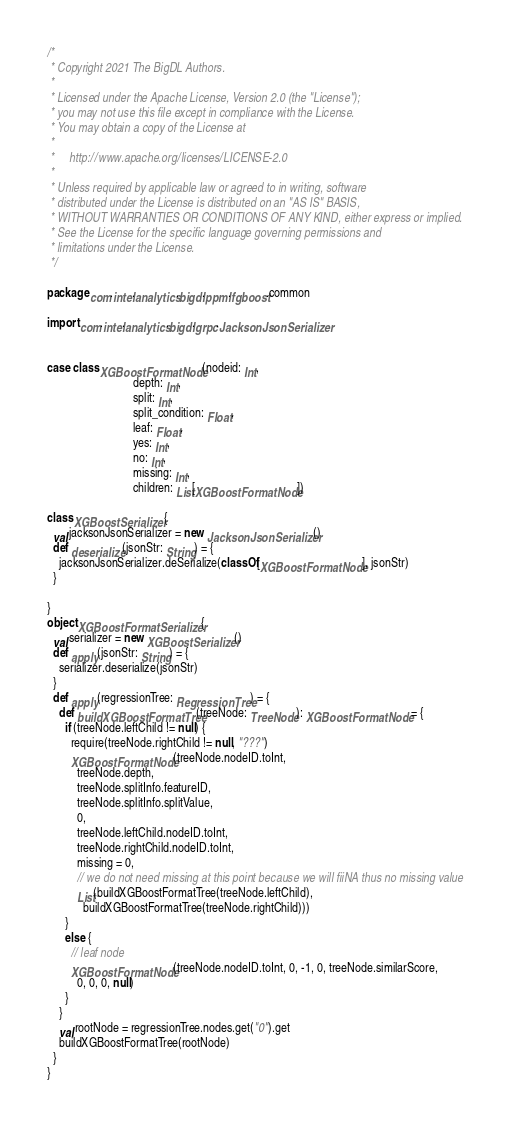<code> <loc_0><loc_0><loc_500><loc_500><_Scala_>/*
 * Copyright 2021 The BigDL Authors.
 *
 * Licensed under the Apache License, Version 2.0 (the "License");
 * you may not use this file except in compliance with the License.
 * You may obtain a copy of the License at
 *
 *     http://www.apache.org/licenses/LICENSE-2.0
 *
 * Unless required by applicable law or agreed to in writing, software
 * distributed under the License is distributed on an "AS IS" BASIS,
 * WITHOUT WARRANTIES OR CONDITIONS OF ANY KIND, either express or implied.
 * See the License for the specific language governing permissions and
 * limitations under the License.
 */

package com.intel.analytics.bigdl.ppml.fgboost.common

import com.intel.analytics.bigdl.grpc.JacksonJsonSerializer


case class XGBoostFormatNode(nodeid: Int,
                             depth: Int,
                             split: Int,
                             split_condition: Float,
                             leaf: Float,
                             yes: Int,
                             no: Int,
                             missing: Int,
                             children: List[XGBoostFormatNode])

class XGBoostSerializer {
  val jacksonJsonSerializer = new JacksonJsonSerializer()
  def deserialize(jsonStr: String) = {
    jacksonJsonSerializer.deSerialize(classOf[XGBoostFormatNode], jsonStr)
  }

}
object XGBoostFormatSerializer {
  val serializer = new XGBoostSerializer()
  def apply(jsonStr: String) = {
    serializer.deserialize(jsonStr)
  }
  def apply(regressionTree: RegressionTree) = {
    def buildXGBoostFormatTree(treeNode: TreeNode): XGBoostFormatNode = {
      if (treeNode.leftChild != null) {
        require(treeNode.rightChild != null, "???")
        XGBoostFormatNode(treeNode.nodeID.toInt,
          treeNode.depth,
          treeNode.splitInfo.featureID,
          treeNode.splitInfo.splitValue,
          0,
          treeNode.leftChild.nodeID.toInt,
          treeNode.rightChild.nodeID.toInt,
          missing = 0,
          // we do not need missing at this point because we will fiiNA thus no missing value
          List(buildXGBoostFormatTree(treeNode.leftChild),
            buildXGBoostFormatTree(treeNode.rightChild)))
      }
      else {
        // leaf node
        XGBoostFormatNode(treeNode.nodeID.toInt, 0, -1, 0, treeNode.similarScore,
          0, 0, 0, null)
      }
    }
    val rootNode = regressionTree.nodes.get("0").get
    buildXGBoostFormatTree(rootNode)
  }
}</code> 